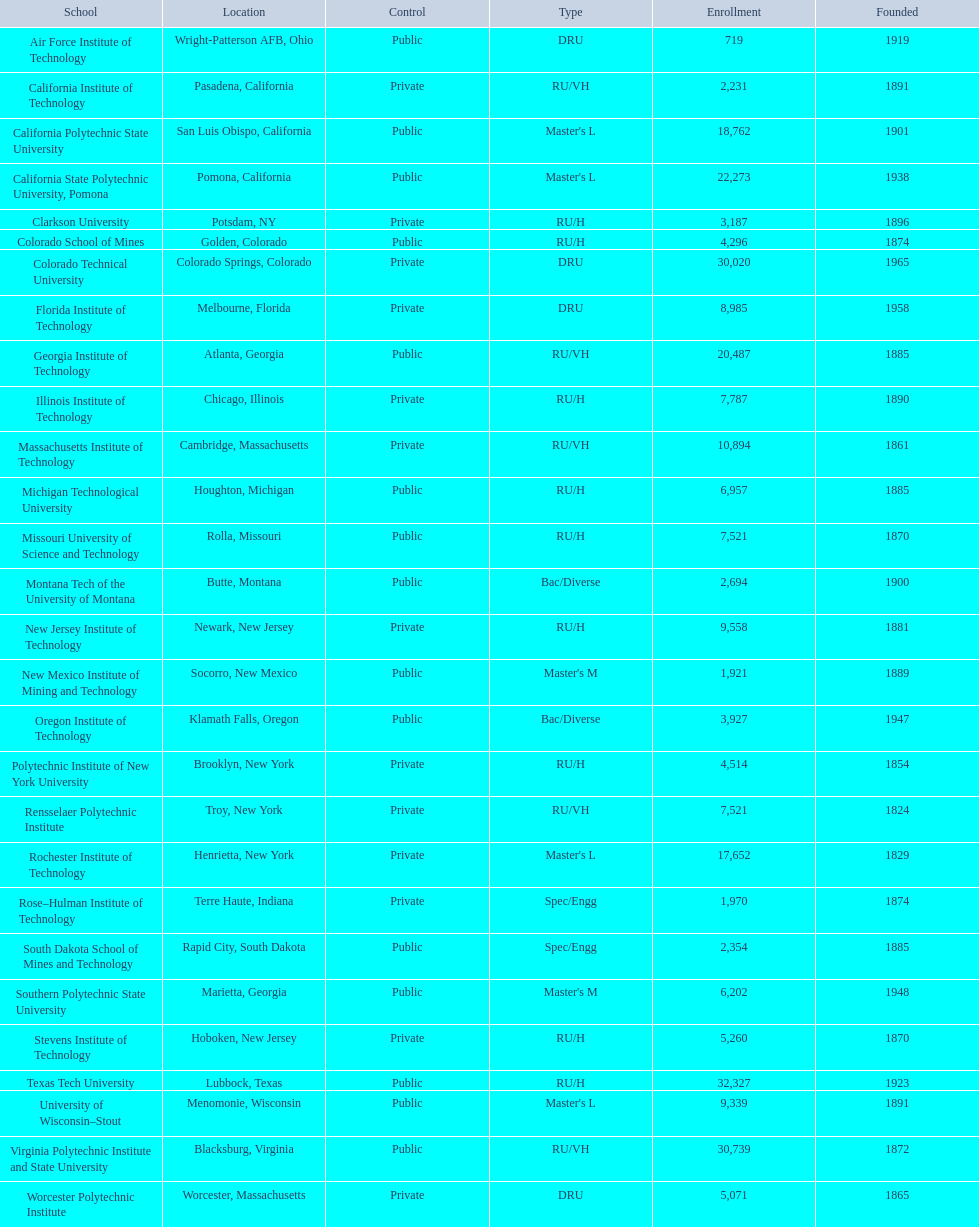What are all the academies? Air Force Institute of Technology, California Institute of Technology, California Polytechnic State University, California State Polytechnic University, Pomona, Clarkson University, Colorado School of Mines, Colorado Technical University, Florida Institute of Technology, Georgia Institute of Technology, Illinois Institute of Technology, Massachusetts Institute of Technology, Michigan Technological University, Missouri University of Science and Technology, Montana Tech of the University of Montana, New Jersey Institute of Technology, New Mexico Institute of Mining and Technology, Oregon Institute of Technology, Polytechnic Institute of New York University, Rensselaer Polytechnic Institute, Rochester Institute of Technology, Rose–Hulman Institute of Technology, South Dakota School of Mines and Technology, Southern Polytechnic State University, Stevens Institute of Technology, Texas Tech University, University of Wisconsin–Stout, Virginia Polytechnic Institute and State University, Worcester Polytechnic Institute. What is the attendance of each academy? 719, 2,231, 18,762, 22,273, 3,187, 4,296, 30,020, 8,985, 20,487, 7,787, 10,894, 6,957, 7,521, 2,694, 9,558, 1,921, 3,927, 4,514, 7,521, 17,652, 1,970, 2,354, 6,202, 5,260, 32,327, 9,339, 30,739, 5,071. And which academy had the greatest attendance? Texas Tech University. 